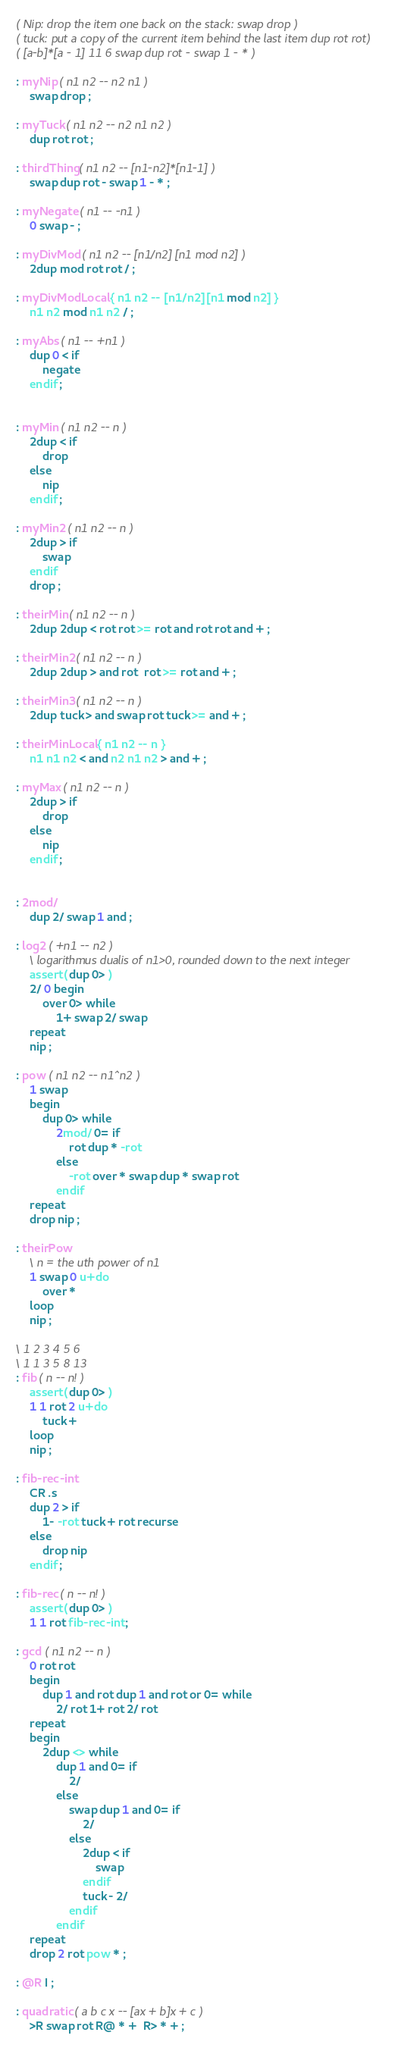Convert code to text. <code><loc_0><loc_0><loc_500><loc_500><_Forth_>( Nip: drop the item one back on the stack: swap drop )
( tuck: put a copy of the current item behind the last item dup rot rot)
( [a-b]*[a - 1] 11 6 swap dup rot - swap 1 - * )

: myNip ( n1 n2 -- n2 n1 )
    swap drop ;

: myTuck ( n1 n2 -- n2 n1 n2 )
    dup rot rot ;

: thirdThing ( n1 n2 -- [n1-n2]*[n1-1] )
    swap dup rot - swap 1 - * ;

: myNegate ( n1 -- -n1 )
    0 swap - ;

: myDivMod ( n1 n2 -- [n1/n2] [n1 mod n2] )
    2dup mod rot rot / ;

: myDivModLocal { n1 n2 -- [n1/n2] [n1 mod n2] }
    n1 n2 mod n1 n2 / ;

: myAbs ( n1 -- +n1 )
    dup 0 < if
        negate
    endif ;


: myMin ( n1 n2 -- n )
    2dup < if
        drop
    else
        nip
    endif ;

: myMin2 ( n1 n2 -- n )
    2dup > if
        swap
    endif
    drop ;

: theirMin ( n1 n2 -- n )
    2dup 2dup < rot rot >= rot and rot rot and + ;

: theirMin2 ( n1 n2 -- n )
    2dup 2dup > and rot  rot >= rot and + ;

: theirMin3 ( n1 n2 -- n )
    2dup tuck > and swap rot tuck >= and + ;

: theirMinLocal { n1 n2 -- n }
    n1 n1 n2 < and n2 n1 n2 > and + ;

: myMax ( n1 n2 -- n )
    2dup > if
        drop
    else
        nip
    endif ;


: 2mod/
    dup 2/ swap 1 and ;

: log2 ( +n1 -- n2 )
    \ logarithmus dualis of n1>0, rounded down to the next integer
    assert( dup 0> )
    2/ 0 begin
        over 0> while
            1+ swap 2/ swap
    repeat
    nip ;

: pow ( n1 n2 -- n1^n2 )
    1 swap
    begin
        dup 0> while
            2mod/ 0= if
                rot dup * -rot
            else
                -rot over * swap dup * swap rot
            endif
    repeat
    drop nip ;
            
: theirPow
    \ n = the uth power of n1
    1 swap 0 u+do
        over *
    loop
    nip ;

\ 1 2 3 4 5 6
\ 1 1 3 5 8 13 
: fib ( n -- n! )
    assert( dup 0> )
    1 1 rot 2 u+do
        tuck +
    loop
    nip ;

: fib-rec-int
    CR .s
    dup 2 > if
        1- -rot tuck + rot recurse
    else
        drop nip
    endif ;

: fib-rec ( n -- n! )
    assert( dup 0> )
    1 1 rot fib-rec-int ;

: gcd ( n1 n2 -- n )
    0 rot rot
    begin
        dup 1 and rot dup 1 and rot or 0= while
            2/ rot 1+ rot 2/ rot
    repeat
    begin
        2dup <> while
            dup 1 and 0= if
                2/
            else
                swap dup 1 and 0= if
                    2/
                else
                    2dup < if
                        swap
                    endif
                    tuck - 2/
                endif
            endif
    repeat
    drop 2 rot pow * ;

: @R I ;

: quadratic ( a b c x -- [ax + b]x + c )
    >R swap rot R@ * +  R> * + ;
</code> 